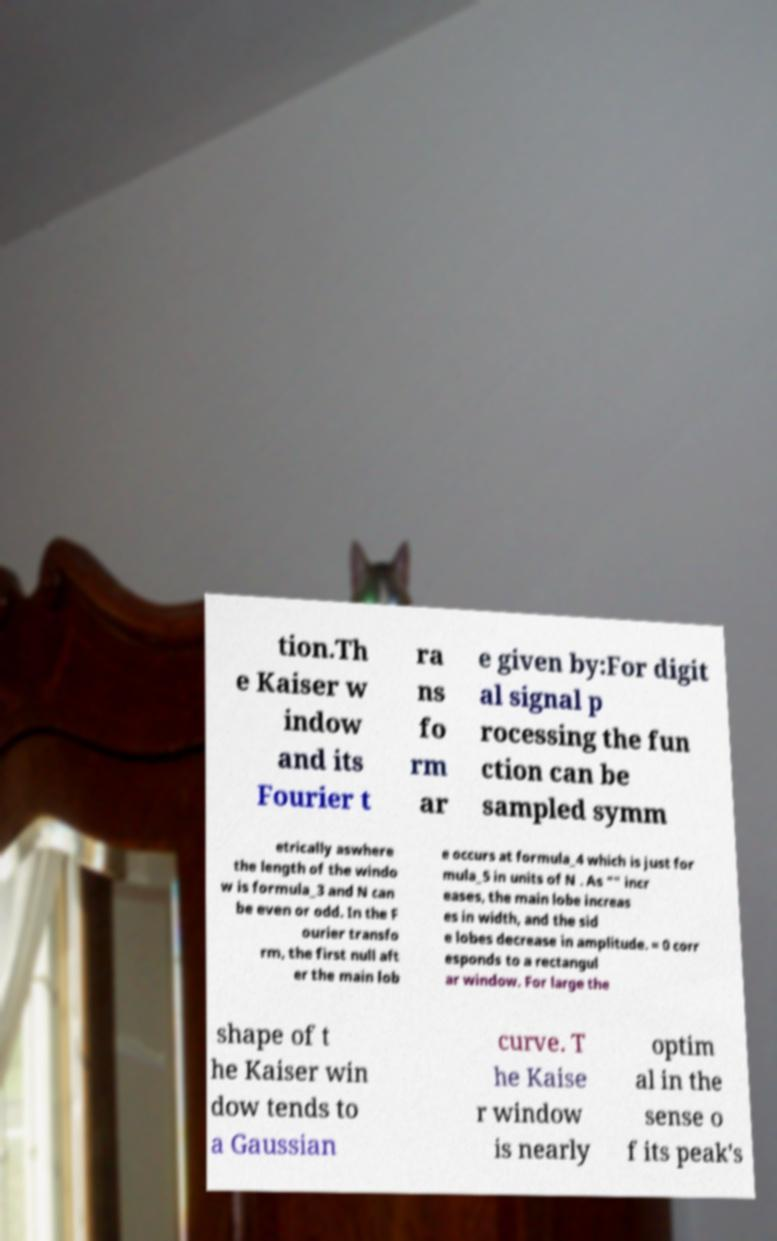Can you read and provide the text displayed in the image?This photo seems to have some interesting text. Can you extract and type it out for me? tion.Th e Kaiser w indow and its Fourier t ra ns fo rm ar e given by:For digit al signal p rocessing the fun ction can be sampled symm etrically aswhere the length of the windo w is formula_3 and N can be even or odd. In the F ourier transfo rm, the first null aft er the main lob e occurs at formula_4 which is just for mula_5 in units of N . As "" incr eases, the main lobe increas es in width, and the sid e lobes decrease in amplitude. = 0 corr esponds to a rectangul ar window. For large the shape of t he Kaiser win dow tends to a Gaussian curve. T he Kaise r window is nearly optim al in the sense o f its peak's 